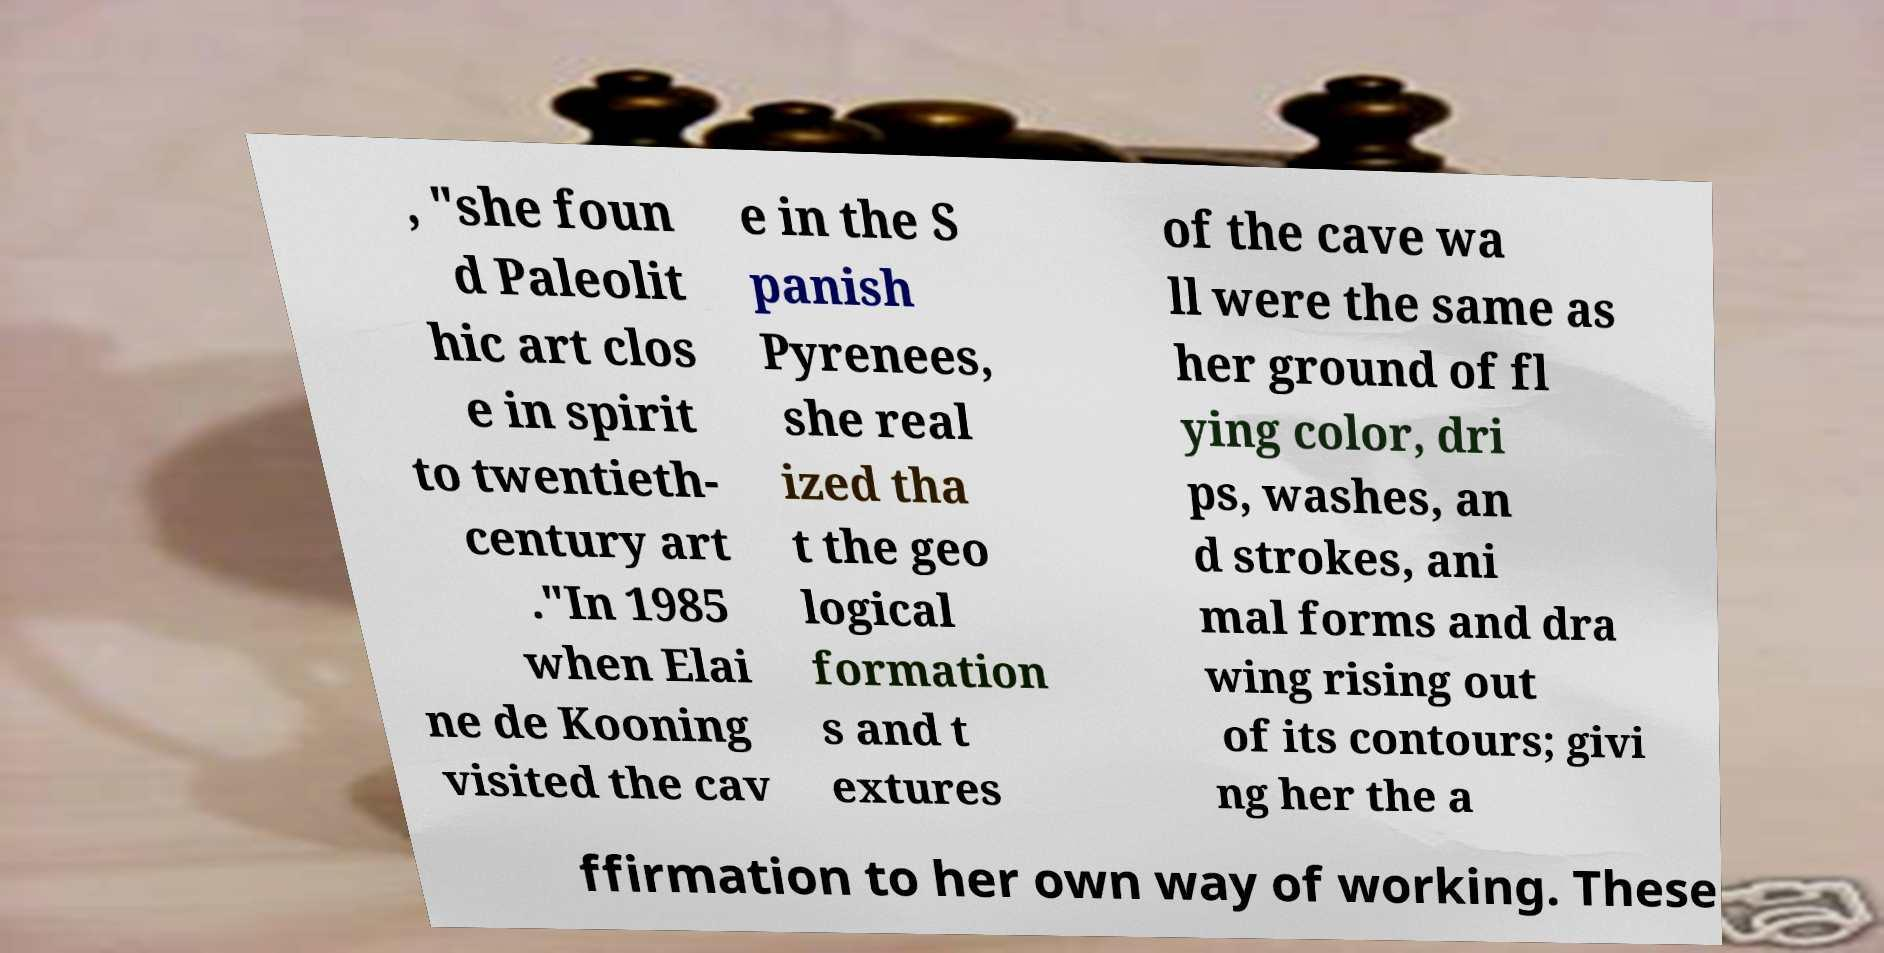Could you assist in decoding the text presented in this image and type it out clearly? , "she foun d Paleolit hic art clos e in spirit to twentieth- century art ."In 1985 when Elai ne de Kooning visited the cav e in the S panish Pyrenees, she real ized tha t the geo logical formation s and t extures of the cave wa ll were the same as her ground of fl ying color, dri ps, washes, an d strokes, ani mal forms and dra wing rising out of its contours; givi ng her the a ffirmation to her own way of working. These 